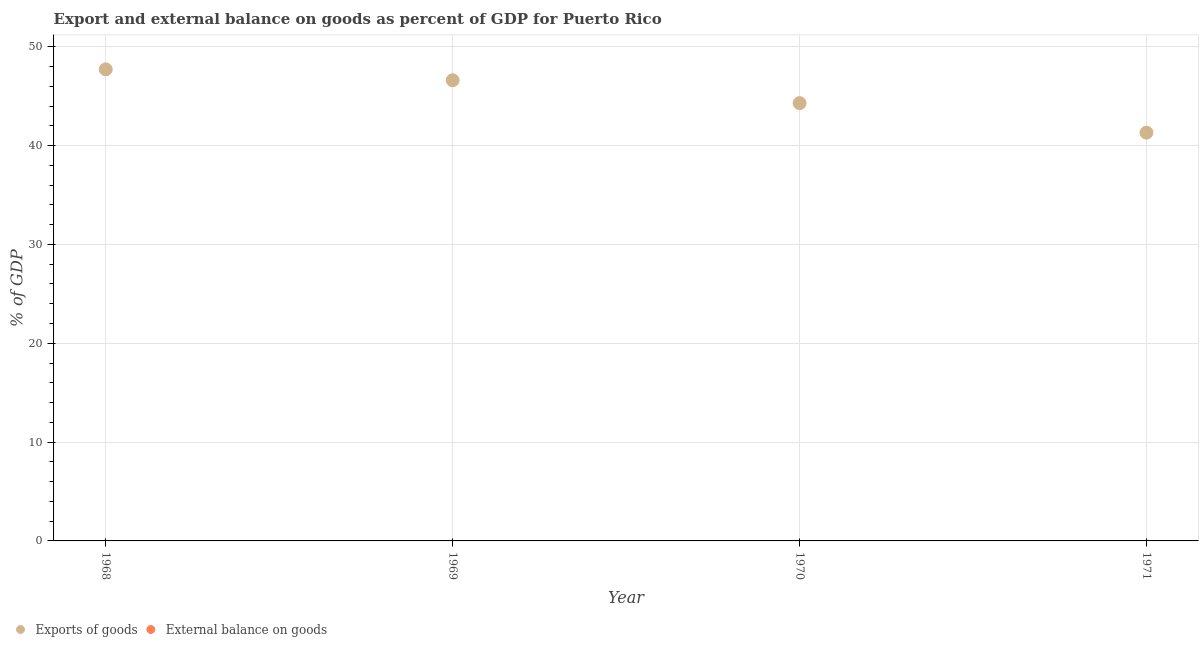What is the external balance on goods as percentage of gdp in 1968?
Ensure brevity in your answer.  0. Across all years, what is the maximum export of goods as percentage of gdp?
Your answer should be compact. 47.72. Across all years, what is the minimum export of goods as percentage of gdp?
Ensure brevity in your answer.  41.32. In which year was the export of goods as percentage of gdp maximum?
Give a very brief answer. 1968. What is the total export of goods as percentage of gdp in the graph?
Give a very brief answer. 179.96. What is the difference between the export of goods as percentage of gdp in 1970 and that in 1971?
Your response must be concise. 2.99. What is the difference between the export of goods as percentage of gdp in 1968 and the external balance on goods as percentage of gdp in 1969?
Keep it short and to the point. 47.72. What is the average external balance on goods as percentage of gdp per year?
Your answer should be compact. 0. In how many years, is the external balance on goods as percentage of gdp greater than 46 %?
Keep it short and to the point. 0. What is the ratio of the export of goods as percentage of gdp in 1968 to that in 1969?
Provide a succinct answer. 1.02. Is the export of goods as percentage of gdp in 1970 less than that in 1971?
Your answer should be compact. No. What is the difference between the highest and the second highest export of goods as percentage of gdp?
Give a very brief answer. 1.1. What is the difference between the highest and the lowest export of goods as percentage of gdp?
Your answer should be compact. 6.41. Does the export of goods as percentage of gdp monotonically increase over the years?
Keep it short and to the point. No. How many dotlines are there?
Ensure brevity in your answer.  1. How many years are there in the graph?
Offer a terse response. 4. What is the difference between two consecutive major ticks on the Y-axis?
Provide a short and direct response. 10. Does the graph contain any zero values?
Ensure brevity in your answer.  Yes. Where does the legend appear in the graph?
Provide a short and direct response. Bottom left. How are the legend labels stacked?
Your response must be concise. Horizontal. What is the title of the graph?
Keep it short and to the point. Export and external balance on goods as percent of GDP for Puerto Rico. Does "Under-5(female)" appear as one of the legend labels in the graph?
Provide a succinct answer. No. What is the label or title of the Y-axis?
Your response must be concise. % of GDP. What is the % of GDP in Exports of goods in 1968?
Make the answer very short. 47.72. What is the % of GDP of Exports of goods in 1969?
Provide a short and direct response. 46.62. What is the % of GDP of Exports of goods in 1970?
Offer a very short reply. 44.3. What is the % of GDP in Exports of goods in 1971?
Your answer should be compact. 41.32. What is the % of GDP in External balance on goods in 1971?
Make the answer very short. 0. Across all years, what is the maximum % of GDP in Exports of goods?
Keep it short and to the point. 47.72. Across all years, what is the minimum % of GDP of Exports of goods?
Offer a very short reply. 41.32. What is the total % of GDP in Exports of goods in the graph?
Your response must be concise. 179.96. What is the difference between the % of GDP in Exports of goods in 1968 and that in 1969?
Your answer should be compact. 1.1. What is the difference between the % of GDP in Exports of goods in 1968 and that in 1970?
Keep it short and to the point. 3.42. What is the difference between the % of GDP in Exports of goods in 1968 and that in 1971?
Ensure brevity in your answer.  6.41. What is the difference between the % of GDP of Exports of goods in 1969 and that in 1970?
Keep it short and to the point. 2.32. What is the difference between the % of GDP of Exports of goods in 1969 and that in 1971?
Make the answer very short. 5.31. What is the difference between the % of GDP in Exports of goods in 1970 and that in 1971?
Provide a succinct answer. 2.99. What is the average % of GDP in Exports of goods per year?
Make the answer very short. 44.99. What is the average % of GDP in External balance on goods per year?
Provide a short and direct response. 0. What is the ratio of the % of GDP in Exports of goods in 1968 to that in 1969?
Your answer should be very brief. 1.02. What is the ratio of the % of GDP of Exports of goods in 1968 to that in 1970?
Offer a terse response. 1.08. What is the ratio of the % of GDP of Exports of goods in 1968 to that in 1971?
Offer a terse response. 1.16. What is the ratio of the % of GDP of Exports of goods in 1969 to that in 1970?
Provide a succinct answer. 1.05. What is the ratio of the % of GDP in Exports of goods in 1969 to that in 1971?
Provide a short and direct response. 1.13. What is the ratio of the % of GDP in Exports of goods in 1970 to that in 1971?
Give a very brief answer. 1.07. What is the difference between the highest and the lowest % of GDP of Exports of goods?
Give a very brief answer. 6.41. 